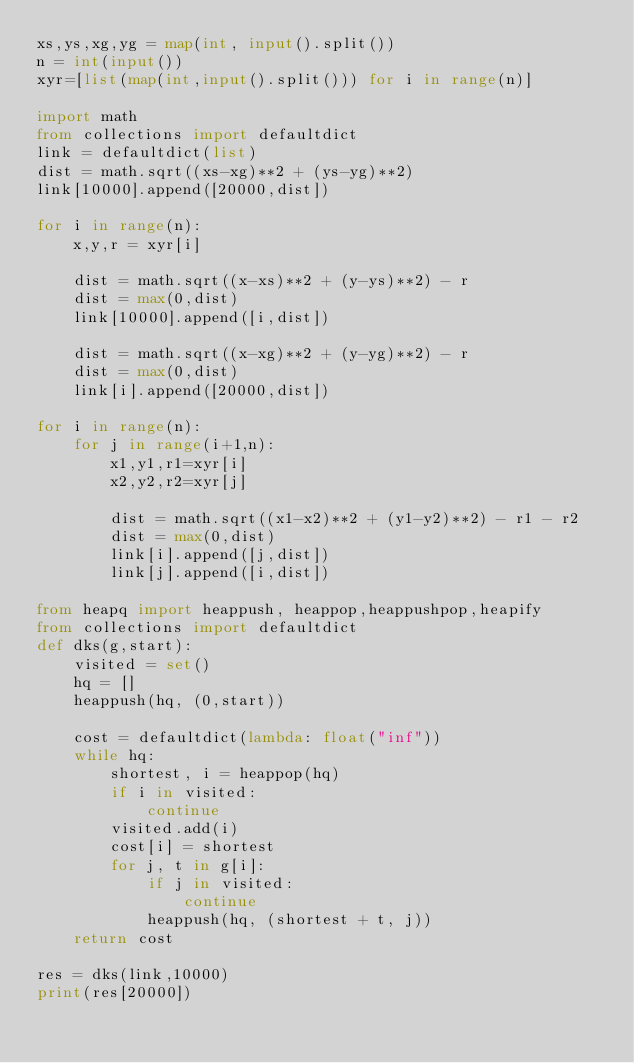Convert code to text. <code><loc_0><loc_0><loc_500><loc_500><_Python_>xs,ys,xg,yg = map(int, input().split())
n = int(input())
xyr=[list(map(int,input().split())) for i in range(n)]

import math
from collections import defaultdict
link = defaultdict(list)
dist = math.sqrt((xs-xg)**2 + (ys-yg)**2)
link[10000].append([20000,dist])

for i in range(n):
    x,y,r = xyr[i]

    dist = math.sqrt((x-xs)**2 + (y-ys)**2) - r
    dist = max(0,dist)
    link[10000].append([i,dist])

    dist = math.sqrt((x-xg)**2 + (y-yg)**2) - r
    dist = max(0,dist)
    link[i].append([20000,dist])

for i in range(n):
    for j in range(i+1,n):
        x1,y1,r1=xyr[i]
        x2,y2,r2=xyr[j]

        dist = math.sqrt((x1-x2)**2 + (y1-y2)**2) - r1 - r2
        dist = max(0,dist)
        link[i].append([j,dist])
        link[j].append([i,dist])

from heapq import heappush, heappop,heappushpop,heapify
from collections import defaultdict
def dks(g,start):
    visited = set()
    hq = []
    heappush(hq, (0,start))

    cost = defaultdict(lambda: float("inf"))
    while hq:
        shortest, i = heappop(hq)
        if i in visited:
            continue
        visited.add(i)
        cost[i] = shortest
        for j, t in g[i]:
            if j in visited:
                continue
            heappush(hq, (shortest + t, j))
    return cost

res = dks(link,10000)
print(res[20000])</code> 